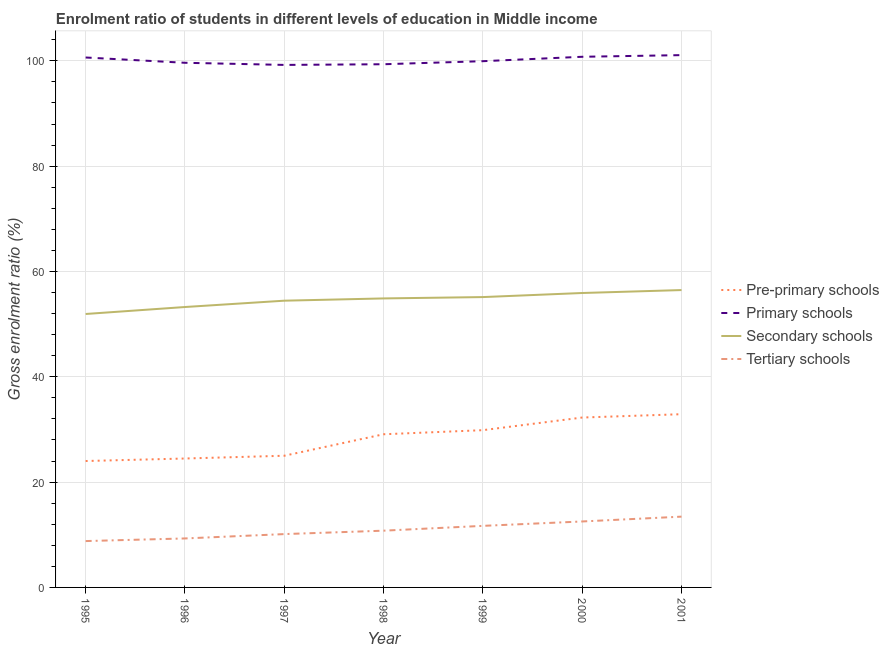Does the line corresponding to gross enrolment ratio in primary schools intersect with the line corresponding to gross enrolment ratio in tertiary schools?
Offer a terse response. No. What is the gross enrolment ratio in tertiary schools in 1995?
Make the answer very short. 8.8. Across all years, what is the maximum gross enrolment ratio in primary schools?
Ensure brevity in your answer.  101.08. Across all years, what is the minimum gross enrolment ratio in primary schools?
Your response must be concise. 99.22. What is the total gross enrolment ratio in primary schools in the graph?
Provide a short and direct response. 700.62. What is the difference between the gross enrolment ratio in secondary schools in 1996 and that in 2000?
Your answer should be very brief. -2.66. What is the difference between the gross enrolment ratio in secondary schools in 1998 and the gross enrolment ratio in primary schools in 1996?
Give a very brief answer. -44.75. What is the average gross enrolment ratio in primary schools per year?
Your response must be concise. 100.09. In the year 2000, what is the difference between the gross enrolment ratio in pre-primary schools and gross enrolment ratio in primary schools?
Your answer should be very brief. -68.51. In how many years, is the gross enrolment ratio in secondary schools greater than 24 %?
Offer a very short reply. 7. What is the ratio of the gross enrolment ratio in secondary schools in 1996 to that in 2000?
Offer a terse response. 0.95. Is the gross enrolment ratio in primary schools in 1998 less than that in 2000?
Make the answer very short. Yes. Is the difference between the gross enrolment ratio in secondary schools in 1996 and 1998 greater than the difference between the gross enrolment ratio in primary schools in 1996 and 1998?
Give a very brief answer. No. What is the difference between the highest and the second highest gross enrolment ratio in secondary schools?
Offer a very short reply. 0.56. What is the difference between the highest and the lowest gross enrolment ratio in secondary schools?
Give a very brief answer. 4.54. In how many years, is the gross enrolment ratio in tertiary schools greater than the average gross enrolment ratio in tertiary schools taken over all years?
Your answer should be very brief. 3. Is it the case that in every year, the sum of the gross enrolment ratio in pre-primary schools and gross enrolment ratio in secondary schools is greater than the sum of gross enrolment ratio in tertiary schools and gross enrolment ratio in primary schools?
Your response must be concise. No. Does the gross enrolment ratio in pre-primary schools monotonically increase over the years?
Offer a terse response. Yes. Is the gross enrolment ratio in secondary schools strictly greater than the gross enrolment ratio in primary schools over the years?
Make the answer very short. No. Is the gross enrolment ratio in tertiary schools strictly less than the gross enrolment ratio in secondary schools over the years?
Offer a terse response. Yes. How many years are there in the graph?
Give a very brief answer. 7. What is the difference between two consecutive major ticks on the Y-axis?
Make the answer very short. 20. Are the values on the major ticks of Y-axis written in scientific E-notation?
Keep it short and to the point. No. Does the graph contain any zero values?
Keep it short and to the point. No. Where does the legend appear in the graph?
Your answer should be very brief. Center right. How many legend labels are there?
Offer a very short reply. 4. What is the title of the graph?
Provide a short and direct response. Enrolment ratio of students in different levels of education in Middle income. What is the label or title of the X-axis?
Offer a very short reply. Year. What is the label or title of the Y-axis?
Offer a very short reply. Gross enrolment ratio (%). What is the Gross enrolment ratio (%) in Pre-primary schools in 1995?
Give a very brief answer. 24.01. What is the Gross enrolment ratio (%) of Primary schools in 1995?
Offer a very short reply. 100.63. What is the Gross enrolment ratio (%) of Secondary schools in 1995?
Give a very brief answer. 51.93. What is the Gross enrolment ratio (%) of Tertiary schools in 1995?
Your answer should be very brief. 8.8. What is the Gross enrolment ratio (%) in Pre-primary schools in 1996?
Give a very brief answer. 24.48. What is the Gross enrolment ratio (%) in Primary schools in 1996?
Your answer should be compact. 99.63. What is the Gross enrolment ratio (%) in Secondary schools in 1996?
Offer a very short reply. 53.25. What is the Gross enrolment ratio (%) in Tertiary schools in 1996?
Your response must be concise. 9.3. What is the Gross enrolment ratio (%) of Pre-primary schools in 1997?
Your answer should be compact. 25.01. What is the Gross enrolment ratio (%) in Primary schools in 1997?
Offer a terse response. 99.22. What is the Gross enrolment ratio (%) of Secondary schools in 1997?
Your answer should be compact. 54.45. What is the Gross enrolment ratio (%) in Tertiary schools in 1997?
Ensure brevity in your answer.  10.13. What is the Gross enrolment ratio (%) of Pre-primary schools in 1998?
Your answer should be very brief. 29.09. What is the Gross enrolment ratio (%) of Primary schools in 1998?
Give a very brief answer. 99.35. What is the Gross enrolment ratio (%) in Secondary schools in 1998?
Provide a short and direct response. 54.88. What is the Gross enrolment ratio (%) in Tertiary schools in 1998?
Offer a very short reply. 10.78. What is the Gross enrolment ratio (%) in Pre-primary schools in 1999?
Provide a short and direct response. 29.86. What is the Gross enrolment ratio (%) in Primary schools in 1999?
Offer a terse response. 99.93. What is the Gross enrolment ratio (%) in Secondary schools in 1999?
Offer a terse response. 55.14. What is the Gross enrolment ratio (%) in Tertiary schools in 1999?
Offer a terse response. 11.69. What is the Gross enrolment ratio (%) in Pre-primary schools in 2000?
Your answer should be compact. 32.26. What is the Gross enrolment ratio (%) of Primary schools in 2000?
Make the answer very short. 100.77. What is the Gross enrolment ratio (%) of Secondary schools in 2000?
Your response must be concise. 55.91. What is the Gross enrolment ratio (%) of Tertiary schools in 2000?
Your response must be concise. 12.53. What is the Gross enrolment ratio (%) in Pre-primary schools in 2001?
Your answer should be very brief. 32.9. What is the Gross enrolment ratio (%) of Primary schools in 2001?
Offer a very short reply. 101.08. What is the Gross enrolment ratio (%) of Secondary schools in 2001?
Keep it short and to the point. 56.47. What is the Gross enrolment ratio (%) in Tertiary schools in 2001?
Ensure brevity in your answer.  13.44. Across all years, what is the maximum Gross enrolment ratio (%) in Pre-primary schools?
Ensure brevity in your answer.  32.9. Across all years, what is the maximum Gross enrolment ratio (%) in Primary schools?
Offer a terse response. 101.08. Across all years, what is the maximum Gross enrolment ratio (%) of Secondary schools?
Provide a short and direct response. 56.47. Across all years, what is the maximum Gross enrolment ratio (%) in Tertiary schools?
Provide a succinct answer. 13.44. Across all years, what is the minimum Gross enrolment ratio (%) in Pre-primary schools?
Your answer should be very brief. 24.01. Across all years, what is the minimum Gross enrolment ratio (%) in Primary schools?
Your answer should be compact. 99.22. Across all years, what is the minimum Gross enrolment ratio (%) of Secondary schools?
Offer a terse response. 51.93. Across all years, what is the minimum Gross enrolment ratio (%) in Tertiary schools?
Keep it short and to the point. 8.8. What is the total Gross enrolment ratio (%) in Pre-primary schools in the graph?
Offer a terse response. 197.6. What is the total Gross enrolment ratio (%) in Primary schools in the graph?
Give a very brief answer. 700.62. What is the total Gross enrolment ratio (%) of Secondary schools in the graph?
Offer a terse response. 382.02. What is the total Gross enrolment ratio (%) in Tertiary schools in the graph?
Make the answer very short. 76.67. What is the difference between the Gross enrolment ratio (%) of Pre-primary schools in 1995 and that in 1996?
Make the answer very short. -0.48. What is the difference between the Gross enrolment ratio (%) of Primary schools in 1995 and that in 1996?
Give a very brief answer. 1. What is the difference between the Gross enrolment ratio (%) of Secondary schools in 1995 and that in 1996?
Offer a very short reply. -1.32. What is the difference between the Gross enrolment ratio (%) of Tertiary schools in 1995 and that in 1996?
Offer a terse response. -0.5. What is the difference between the Gross enrolment ratio (%) of Pre-primary schools in 1995 and that in 1997?
Provide a short and direct response. -1. What is the difference between the Gross enrolment ratio (%) of Primary schools in 1995 and that in 1997?
Provide a succinct answer. 1.41. What is the difference between the Gross enrolment ratio (%) of Secondary schools in 1995 and that in 1997?
Keep it short and to the point. -2.53. What is the difference between the Gross enrolment ratio (%) in Tertiary schools in 1995 and that in 1997?
Offer a terse response. -1.33. What is the difference between the Gross enrolment ratio (%) in Pre-primary schools in 1995 and that in 1998?
Provide a short and direct response. -5.08. What is the difference between the Gross enrolment ratio (%) in Primary schools in 1995 and that in 1998?
Offer a very short reply. 1.28. What is the difference between the Gross enrolment ratio (%) of Secondary schools in 1995 and that in 1998?
Keep it short and to the point. -2.95. What is the difference between the Gross enrolment ratio (%) of Tertiary schools in 1995 and that in 1998?
Offer a very short reply. -1.97. What is the difference between the Gross enrolment ratio (%) of Pre-primary schools in 1995 and that in 1999?
Make the answer very short. -5.86. What is the difference between the Gross enrolment ratio (%) of Primary schools in 1995 and that in 1999?
Give a very brief answer. 0.7. What is the difference between the Gross enrolment ratio (%) of Secondary schools in 1995 and that in 1999?
Make the answer very short. -3.21. What is the difference between the Gross enrolment ratio (%) of Tertiary schools in 1995 and that in 1999?
Your answer should be very brief. -2.89. What is the difference between the Gross enrolment ratio (%) of Pre-primary schools in 1995 and that in 2000?
Keep it short and to the point. -8.26. What is the difference between the Gross enrolment ratio (%) in Primary schools in 1995 and that in 2000?
Your response must be concise. -0.14. What is the difference between the Gross enrolment ratio (%) of Secondary schools in 1995 and that in 2000?
Make the answer very short. -3.99. What is the difference between the Gross enrolment ratio (%) in Tertiary schools in 1995 and that in 2000?
Offer a very short reply. -3.72. What is the difference between the Gross enrolment ratio (%) of Pre-primary schools in 1995 and that in 2001?
Ensure brevity in your answer.  -8.89. What is the difference between the Gross enrolment ratio (%) in Primary schools in 1995 and that in 2001?
Provide a short and direct response. -0.45. What is the difference between the Gross enrolment ratio (%) in Secondary schools in 1995 and that in 2001?
Offer a very short reply. -4.54. What is the difference between the Gross enrolment ratio (%) in Tertiary schools in 1995 and that in 2001?
Make the answer very short. -4.64. What is the difference between the Gross enrolment ratio (%) of Pre-primary schools in 1996 and that in 1997?
Ensure brevity in your answer.  -0.52. What is the difference between the Gross enrolment ratio (%) of Primary schools in 1996 and that in 1997?
Your answer should be very brief. 0.41. What is the difference between the Gross enrolment ratio (%) in Secondary schools in 1996 and that in 1997?
Provide a short and direct response. -1.2. What is the difference between the Gross enrolment ratio (%) in Tertiary schools in 1996 and that in 1997?
Make the answer very short. -0.83. What is the difference between the Gross enrolment ratio (%) in Pre-primary schools in 1996 and that in 1998?
Make the answer very short. -4.6. What is the difference between the Gross enrolment ratio (%) of Primary schools in 1996 and that in 1998?
Ensure brevity in your answer.  0.28. What is the difference between the Gross enrolment ratio (%) of Secondary schools in 1996 and that in 1998?
Your answer should be very brief. -1.63. What is the difference between the Gross enrolment ratio (%) in Tertiary schools in 1996 and that in 1998?
Provide a succinct answer. -1.47. What is the difference between the Gross enrolment ratio (%) in Pre-primary schools in 1996 and that in 1999?
Your response must be concise. -5.38. What is the difference between the Gross enrolment ratio (%) of Primary schools in 1996 and that in 1999?
Your response must be concise. -0.3. What is the difference between the Gross enrolment ratio (%) in Secondary schools in 1996 and that in 1999?
Give a very brief answer. -1.89. What is the difference between the Gross enrolment ratio (%) in Tertiary schools in 1996 and that in 1999?
Your answer should be very brief. -2.39. What is the difference between the Gross enrolment ratio (%) in Pre-primary schools in 1996 and that in 2000?
Give a very brief answer. -7.78. What is the difference between the Gross enrolment ratio (%) in Primary schools in 1996 and that in 2000?
Provide a short and direct response. -1.14. What is the difference between the Gross enrolment ratio (%) in Secondary schools in 1996 and that in 2000?
Provide a short and direct response. -2.66. What is the difference between the Gross enrolment ratio (%) in Tertiary schools in 1996 and that in 2000?
Provide a succinct answer. -3.22. What is the difference between the Gross enrolment ratio (%) of Pre-primary schools in 1996 and that in 2001?
Keep it short and to the point. -8.42. What is the difference between the Gross enrolment ratio (%) in Primary schools in 1996 and that in 2001?
Your answer should be very brief. -1.45. What is the difference between the Gross enrolment ratio (%) of Secondary schools in 1996 and that in 2001?
Make the answer very short. -3.22. What is the difference between the Gross enrolment ratio (%) of Tertiary schools in 1996 and that in 2001?
Ensure brevity in your answer.  -4.14. What is the difference between the Gross enrolment ratio (%) of Pre-primary schools in 1997 and that in 1998?
Provide a succinct answer. -4.08. What is the difference between the Gross enrolment ratio (%) of Primary schools in 1997 and that in 1998?
Give a very brief answer. -0.13. What is the difference between the Gross enrolment ratio (%) of Secondary schools in 1997 and that in 1998?
Make the answer very short. -0.43. What is the difference between the Gross enrolment ratio (%) of Tertiary schools in 1997 and that in 1998?
Give a very brief answer. -0.65. What is the difference between the Gross enrolment ratio (%) of Pre-primary schools in 1997 and that in 1999?
Keep it short and to the point. -4.86. What is the difference between the Gross enrolment ratio (%) in Primary schools in 1997 and that in 1999?
Give a very brief answer. -0.71. What is the difference between the Gross enrolment ratio (%) of Secondary schools in 1997 and that in 1999?
Your response must be concise. -0.69. What is the difference between the Gross enrolment ratio (%) in Tertiary schools in 1997 and that in 1999?
Keep it short and to the point. -1.56. What is the difference between the Gross enrolment ratio (%) in Pre-primary schools in 1997 and that in 2000?
Give a very brief answer. -7.26. What is the difference between the Gross enrolment ratio (%) of Primary schools in 1997 and that in 2000?
Provide a short and direct response. -1.55. What is the difference between the Gross enrolment ratio (%) in Secondary schools in 1997 and that in 2000?
Your response must be concise. -1.46. What is the difference between the Gross enrolment ratio (%) of Tertiary schools in 1997 and that in 2000?
Your response must be concise. -2.4. What is the difference between the Gross enrolment ratio (%) in Pre-primary schools in 1997 and that in 2001?
Your answer should be very brief. -7.89. What is the difference between the Gross enrolment ratio (%) of Primary schools in 1997 and that in 2001?
Make the answer very short. -1.86. What is the difference between the Gross enrolment ratio (%) in Secondary schools in 1997 and that in 2001?
Provide a short and direct response. -2.02. What is the difference between the Gross enrolment ratio (%) of Tertiary schools in 1997 and that in 2001?
Your response must be concise. -3.31. What is the difference between the Gross enrolment ratio (%) of Pre-primary schools in 1998 and that in 1999?
Your answer should be compact. -0.78. What is the difference between the Gross enrolment ratio (%) of Primary schools in 1998 and that in 1999?
Provide a succinct answer. -0.58. What is the difference between the Gross enrolment ratio (%) in Secondary schools in 1998 and that in 1999?
Ensure brevity in your answer.  -0.26. What is the difference between the Gross enrolment ratio (%) in Tertiary schools in 1998 and that in 1999?
Ensure brevity in your answer.  -0.92. What is the difference between the Gross enrolment ratio (%) in Pre-primary schools in 1998 and that in 2000?
Offer a very short reply. -3.18. What is the difference between the Gross enrolment ratio (%) in Primary schools in 1998 and that in 2000?
Offer a very short reply. -1.42. What is the difference between the Gross enrolment ratio (%) in Secondary schools in 1998 and that in 2000?
Make the answer very short. -1.03. What is the difference between the Gross enrolment ratio (%) in Tertiary schools in 1998 and that in 2000?
Your response must be concise. -1.75. What is the difference between the Gross enrolment ratio (%) in Pre-primary schools in 1998 and that in 2001?
Your answer should be very brief. -3.81. What is the difference between the Gross enrolment ratio (%) of Primary schools in 1998 and that in 2001?
Offer a very short reply. -1.73. What is the difference between the Gross enrolment ratio (%) in Secondary schools in 1998 and that in 2001?
Your answer should be very brief. -1.59. What is the difference between the Gross enrolment ratio (%) in Tertiary schools in 1998 and that in 2001?
Give a very brief answer. -2.67. What is the difference between the Gross enrolment ratio (%) in Pre-primary schools in 1999 and that in 2000?
Keep it short and to the point. -2.4. What is the difference between the Gross enrolment ratio (%) in Primary schools in 1999 and that in 2000?
Offer a terse response. -0.84. What is the difference between the Gross enrolment ratio (%) of Secondary schools in 1999 and that in 2000?
Make the answer very short. -0.77. What is the difference between the Gross enrolment ratio (%) in Pre-primary schools in 1999 and that in 2001?
Offer a terse response. -3.03. What is the difference between the Gross enrolment ratio (%) in Primary schools in 1999 and that in 2001?
Keep it short and to the point. -1.15. What is the difference between the Gross enrolment ratio (%) in Secondary schools in 1999 and that in 2001?
Keep it short and to the point. -1.33. What is the difference between the Gross enrolment ratio (%) of Tertiary schools in 1999 and that in 2001?
Your answer should be compact. -1.75. What is the difference between the Gross enrolment ratio (%) of Pre-primary schools in 2000 and that in 2001?
Offer a terse response. -0.64. What is the difference between the Gross enrolment ratio (%) in Primary schools in 2000 and that in 2001?
Offer a very short reply. -0.31. What is the difference between the Gross enrolment ratio (%) in Secondary schools in 2000 and that in 2001?
Provide a short and direct response. -0.56. What is the difference between the Gross enrolment ratio (%) of Tertiary schools in 2000 and that in 2001?
Your answer should be compact. -0.92. What is the difference between the Gross enrolment ratio (%) of Pre-primary schools in 1995 and the Gross enrolment ratio (%) of Primary schools in 1996?
Give a very brief answer. -75.62. What is the difference between the Gross enrolment ratio (%) of Pre-primary schools in 1995 and the Gross enrolment ratio (%) of Secondary schools in 1996?
Offer a terse response. -29.24. What is the difference between the Gross enrolment ratio (%) of Pre-primary schools in 1995 and the Gross enrolment ratio (%) of Tertiary schools in 1996?
Provide a short and direct response. 14.7. What is the difference between the Gross enrolment ratio (%) of Primary schools in 1995 and the Gross enrolment ratio (%) of Secondary schools in 1996?
Provide a short and direct response. 47.38. What is the difference between the Gross enrolment ratio (%) in Primary schools in 1995 and the Gross enrolment ratio (%) in Tertiary schools in 1996?
Ensure brevity in your answer.  91.33. What is the difference between the Gross enrolment ratio (%) of Secondary schools in 1995 and the Gross enrolment ratio (%) of Tertiary schools in 1996?
Give a very brief answer. 42.62. What is the difference between the Gross enrolment ratio (%) in Pre-primary schools in 1995 and the Gross enrolment ratio (%) in Primary schools in 1997?
Give a very brief answer. -75.22. What is the difference between the Gross enrolment ratio (%) of Pre-primary schools in 1995 and the Gross enrolment ratio (%) of Secondary schools in 1997?
Make the answer very short. -30.45. What is the difference between the Gross enrolment ratio (%) of Pre-primary schools in 1995 and the Gross enrolment ratio (%) of Tertiary schools in 1997?
Provide a short and direct response. 13.88. What is the difference between the Gross enrolment ratio (%) in Primary schools in 1995 and the Gross enrolment ratio (%) in Secondary schools in 1997?
Provide a succinct answer. 46.18. What is the difference between the Gross enrolment ratio (%) in Primary schools in 1995 and the Gross enrolment ratio (%) in Tertiary schools in 1997?
Your response must be concise. 90.5. What is the difference between the Gross enrolment ratio (%) in Secondary schools in 1995 and the Gross enrolment ratio (%) in Tertiary schools in 1997?
Make the answer very short. 41.8. What is the difference between the Gross enrolment ratio (%) in Pre-primary schools in 1995 and the Gross enrolment ratio (%) in Primary schools in 1998?
Keep it short and to the point. -75.35. What is the difference between the Gross enrolment ratio (%) in Pre-primary schools in 1995 and the Gross enrolment ratio (%) in Secondary schools in 1998?
Offer a very short reply. -30.88. What is the difference between the Gross enrolment ratio (%) of Pre-primary schools in 1995 and the Gross enrolment ratio (%) of Tertiary schools in 1998?
Give a very brief answer. 13.23. What is the difference between the Gross enrolment ratio (%) in Primary schools in 1995 and the Gross enrolment ratio (%) in Secondary schools in 1998?
Offer a terse response. 45.75. What is the difference between the Gross enrolment ratio (%) of Primary schools in 1995 and the Gross enrolment ratio (%) of Tertiary schools in 1998?
Keep it short and to the point. 89.86. What is the difference between the Gross enrolment ratio (%) in Secondary schools in 1995 and the Gross enrolment ratio (%) in Tertiary schools in 1998?
Provide a succinct answer. 41.15. What is the difference between the Gross enrolment ratio (%) of Pre-primary schools in 1995 and the Gross enrolment ratio (%) of Primary schools in 1999?
Keep it short and to the point. -75.93. What is the difference between the Gross enrolment ratio (%) in Pre-primary schools in 1995 and the Gross enrolment ratio (%) in Secondary schools in 1999?
Offer a very short reply. -31.13. What is the difference between the Gross enrolment ratio (%) of Pre-primary schools in 1995 and the Gross enrolment ratio (%) of Tertiary schools in 1999?
Give a very brief answer. 12.31. What is the difference between the Gross enrolment ratio (%) of Primary schools in 1995 and the Gross enrolment ratio (%) of Secondary schools in 1999?
Your response must be concise. 45.5. What is the difference between the Gross enrolment ratio (%) of Primary schools in 1995 and the Gross enrolment ratio (%) of Tertiary schools in 1999?
Give a very brief answer. 88.94. What is the difference between the Gross enrolment ratio (%) of Secondary schools in 1995 and the Gross enrolment ratio (%) of Tertiary schools in 1999?
Offer a very short reply. 40.23. What is the difference between the Gross enrolment ratio (%) in Pre-primary schools in 1995 and the Gross enrolment ratio (%) in Primary schools in 2000?
Provide a succinct answer. -76.76. What is the difference between the Gross enrolment ratio (%) in Pre-primary schools in 1995 and the Gross enrolment ratio (%) in Secondary schools in 2000?
Offer a very short reply. -31.91. What is the difference between the Gross enrolment ratio (%) of Pre-primary schools in 1995 and the Gross enrolment ratio (%) of Tertiary schools in 2000?
Provide a succinct answer. 11.48. What is the difference between the Gross enrolment ratio (%) of Primary schools in 1995 and the Gross enrolment ratio (%) of Secondary schools in 2000?
Ensure brevity in your answer.  44.72. What is the difference between the Gross enrolment ratio (%) in Primary schools in 1995 and the Gross enrolment ratio (%) in Tertiary schools in 2000?
Make the answer very short. 88.11. What is the difference between the Gross enrolment ratio (%) of Secondary schools in 1995 and the Gross enrolment ratio (%) of Tertiary schools in 2000?
Give a very brief answer. 39.4. What is the difference between the Gross enrolment ratio (%) in Pre-primary schools in 1995 and the Gross enrolment ratio (%) in Primary schools in 2001?
Offer a terse response. -77.08. What is the difference between the Gross enrolment ratio (%) of Pre-primary schools in 1995 and the Gross enrolment ratio (%) of Secondary schools in 2001?
Ensure brevity in your answer.  -32.46. What is the difference between the Gross enrolment ratio (%) in Pre-primary schools in 1995 and the Gross enrolment ratio (%) in Tertiary schools in 2001?
Your answer should be very brief. 10.56. What is the difference between the Gross enrolment ratio (%) in Primary schools in 1995 and the Gross enrolment ratio (%) in Secondary schools in 2001?
Keep it short and to the point. 44.16. What is the difference between the Gross enrolment ratio (%) of Primary schools in 1995 and the Gross enrolment ratio (%) of Tertiary schools in 2001?
Offer a terse response. 87.19. What is the difference between the Gross enrolment ratio (%) of Secondary schools in 1995 and the Gross enrolment ratio (%) of Tertiary schools in 2001?
Give a very brief answer. 38.48. What is the difference between the Gross enrolment ratio (%) of Pre-primary schools in 1996 and the Gross enrolment ratio (%) of Primary schools in 1997?
Ensure brevity in your answer.  -74.74. What is the difference between the Gross enrolment ratio (%) in Pre-primary schools in 1996 and the Gross enrolment ratio (%) in Secondary schools in 1997?
Provide a succinct answer. -29.97. What is the difference between the Gross enrolment ratio (%) in Pre-primary schools in 1996 and the Gross enrolment ratio (%) in Tertiary schools in 1997?
Provide a succinct answer. 14.35. What is the difference between the Gross enrolment ratio (%) of Primary schools in 1996 and the Gross enrolment ratio (%) of Secondary schools in 1997?
Keep it short and to the point. 45.18. What is the difference between the Gross enrolment ratio (%) in Primary schools in 1996 and the Gross enrolment ratio (%) in Tertiary schools in 1997?
Ensure brevity in your answer.  89.5. What is the difference between the Gross enrolment ratio (%) of Secondary schools in 1996 and the Gross enrolment ratio (%) of Tertiary schools in 1997?
Ensure brevity in your answer.  43.12. What is the difference between the Gross enrolment ratio (%) of Pre-primary schools in 1996 and the Gross enrolment ratio (%) of Primary schools in 1998?
Give a very brief answer. -74.87. What is the difference between the Gross enrolment ratio (%) of Pre-primary schools in 1996 and the Gross enrolment ratio (%) of Secondary schools in 1998?
Provide a short and direct response. -30.4. What is the difference between the Gross enrolment ratio (%) of Pre-primary schools in 1996 and the Gross enrolment ratio (%) of Tertiary schools in 1998?
Offer a terse response. 13.7. What is the difference between the Gross enrolment ratio (%) of Primary schools in 1996 and the Gross enrolment ratio (%) of Secondary schools in 1998?
Offer a terse response. 44.75. What is the difference between the Gross enrolment ratio (%) in Primary schools in 1996 and the Gross enrolment ratio (%) in Tertiary schools in 1998?
Give a very brief answer. 88.85. What is the difference between the Gross enrolment ratio (%) of Secondary schools in 1996 and the Gross enrolment ratio (%) of Tertiary schools in 1998?
Your answer should be very brief. 42.47. What is the difference between the Gross enrolment ratio (%) in Pre-primary schools in 1996 and the Gross enrolment ratio (%) in Primary schools in 1999?
Make the answer very short. -75.45. What is the difference between the Gross enrolment ratio (%) of Pre-primary schools in 1996 and the Gross enrolment ratio (%) of Secondary schools in 1999?
Offer a terse response. -30.66. What is the difference between the Gross enrolment ratio (%) in Pre-primary schools in 1996 and the Gross enrolment ratio (%) in Tertiary schools in 1999?
Ensure brevity in your answer.  12.79. What is the difference between the Gross enrolment ratio (%) of Primary schools in 1996 and the Gross enrolment ratio (%) of Secondary schools in 1999?
Your answer should be compact. 44.49. What is the difference between the Gross enrolment ratio (%) in Primary schools in 1996 and the Gross enrolment ratio (%) in Tertiary schools in 1999?
Keep it short and to the point. 87.94. What is the difference between the Gross enrolment ratio (%) of Secondary schools in 1996 and the Gross enrolment ratio (%) of Tertiary schools in 1999?
Your answer should be very brief. 41.56. What is the difference between the Gross enrolment ratio (%) in Pre-primary schools in 1996 and the Gross enrolment ratio (%) in Primary schools in 2000?
Keep it short and to the point. -76.29. What is the difference between the Gross enrolment ratio (%) in Pre-primary schools in 1996 and the Gross enrolment ratio (%) in Secondary schools in 2000?
Provide a succinct answer. -31.43. What is the difference between the Gross enrolment ratio (%) in Pre-primary schools in 1996 and the Gross enrolment ratio (%) in Tertiary schools in 2000?
Make the answer very short. 11.96. What is the difference between the Gross enrolment ratio (%) of Primary schools in 1996 and the Gross enrolment ratio (%) of Secondary schools in 2000?
Offer a very short reply. 43.72. What is the difference between the Gross enrolment ratio (%) of Primary schools in 1996 and the Gross enrolment ratio (%) of Tertiary schools in 2000?
Provide a succinct answer. 87.1. What is the difference between the Gross enrolment ratio (%) of Secondary schools in 1996 and the Gross enrolment ratio (%) of Tertiary schools in 2000?
Offer a terse response. 40.72. What is the difference between the Gross enrolment ratio (%) of Pre-primary schools in 1996 and the Gross enrolment ratio (%) of Primary schools in 2001?
Your answer should be very brief. -76.6. What is the difference between the Gross enrolment ratio (%) in Pre-primary schools in 1996 and the Gross enrolment ratio (%) in Secondary schools in 2001?
Give a very brief answer. -31.99. What is the difference between the Gross enrolment ratio (%) of Pre-primary schools in 1996 and the Gross enrolment ratio (%) of Tertiary schools in 2001?
Provide a short and direct response. 11.04. What is the difference between the Gross enrolment ratio (%) in Primary schools in 1996 and the Gross enrolment ratio (%) in Secondary schools in 2001?
Provide a succinct answer. 43.16. What is the difference between the Gross enrolment ratio (%) of Primary schools in 1996 and the Gross enrolment ratio (%) of Tertiary schools in 2001?
Provide a short and direct response. 86.19. What is the difference between the Gross enrolment ratio (%) in Secondary schools in 1996 and the Gross enrolment ratio (%) in Tertiary schools in 2001?
Offer a terse response. 39.81. What is the difference between the Gross enrolment ratio (%) of Pre-primary schools in 1997 and the Gross enrolment ratio (%) of Primary schools in 1998?
Provide a succinct answer. -74.35. What is the difference between the Gross enrolment ratio (%) of Pre-primary schools in 1997 and the Gross enrolment ratio (%) of Secondary schools in 1998?
Offer a terse response. -29.87. What is the difference between the Gross enrolment ratio (%) in Pre-primary schools in 1997 and the Gross enrolment ratio (%) in Tertiary schools in 1998?
Your answer should be compact. 14.23. What is the difference between the Gross enrolment ratio (%) of Primary schools in 1997 and the Gross enrolment ratio (%) of Secondary schools in 1998?
Ensure brevity in your answer.  44.34. What is the difference between the Gross enrolment ratio (%) of Primary schools in 1997 and the Gross enrolment ratio (%) of Tertiary schools in 1998?
Make the answer very short. 88.45. What is the difference between the Gross enrolment ratio (%) of Secondary schools in 1997 and the Gross enrolment ratio (%) of Tertiary schools in 1998?
Your answer should be compact. 43.67. What is the difference between the Gross enrolment ratio (%) in Pre-primary schools in 1997 and the Gross enrolment ratio (%) in Primary schools in 1999?
Ensure brevity in your answer.  -74.93. What is the difference between the Gross enrolment ratio (%) of Pre-primary schools in 1997 and the Gross enrolment ratio (%) of Secondary schools in 1999?
Make the answer very short. -30.13. What is the difference between the Gross enrolment ratio (%) of Pre-primary schools in 1997 and the Gross enrolment ratio (%) of Tertiary schools in 1999?
Provide a succinct answer. 13.31. What is the difference between the Gross enrolment ratio (%) of Primary schools in 1997 and the Gross enrolment ratio (%) of Secondary schools in 1999?
Your answer should be very brief. 44.09. What is the difference between the Gross enrolment ratio (%) of Primary schools in 1997 and the Gross enrolment ratio (%) of Tertiary schools in 1999?
Provide a succinct answer. 87.53. What is the difference between the Gross enrolment ratio (%) of Secondary schools in 1997 and the Gross enrolment ratio (%) of Tertiary schools in 1999?
Offer a very short reply. 42.76. What is the difference between the Gross enrolment ratio (%) of Pre-primary schools in 1997 and the Gross enrolment ratio (%) of Primary schools in 2000?
Keep it short and to the point. -75.76. What is the difference between the Gross enrolment ratio (%) of Pre-primary schools in 1997 and the Gross enrolment ratio (%) of Secondary schools in 2000?
Your answer should be compact. -30.91. What is the difference between the Gross enrolment ratio (%) of Pre-primary schools in 1997 and the Gross enrolment ratio (%) of Tertiary schools in 2000?
Make the answer very short. 12.48. What is the difference between the Gross enrolment ratio (%) in Primary schools in 1997 and the Gross enrolment ratio (%) in Secondary schools in 2000?
Your answer should be compact. 43.31. What is the difference between the Gross enrolment ratio (%) of Primary schools in 1997 and the Gross enrolment ratio (%) of Tertiary schools in 2000?
Your answer should be very brief. 86.7. What is the difference between the Gross enrolment ratio (%) in Secondary schools in 1997 and the Gross enrolment ratio (%) in Tertiary schools in 2000?
Your response must be concise. 41.93. What is the difference between the Gross enrolment ratio (%) in Pre-primary schools in 1997 and the Gross enrolment ratio (%) in Primary schools in 2001?
Ensure brevity in your answer.  -76.08. What is the difference between the Gross enrolment ratio (%) of Pre-primary schools in 1997 and the Gross enrolment ratio (%) of Secondary schools in 2001?
Make the answer very short. -31.46. What is the difference between the Gross enrolment ratio (%) of Pre-primary schools in 1997 and the Gross enrolment ratio (%) of Tertiary schools in 2001?
Provide a succinct answer. 11.56. What is the difference between the Gross enrolment ratio (%) in Primary schools in 1997 and the Gross enrolment ratio (%) in Secondary schools in 2001?
Offer a terse response. 42.75. What is the difference between the Gross enrolment ratio (%) in Primary schools in 1997 and the Gross enrolment ratio (%) in Tertiary schools in 2001?
Ensure brevity in your answer.  85.78. What is the difference between the Gross enrolment ratio (%) of Secondary schools in 1997 and the Gross enrolment ratio (%) of Tertiary schools in 2001?
Offer a terse response. 41.01. What is the difference between the Gross enrolment ratio (%) of Pre-primary schools in 1998 and the Gross enrolment ratio (%) of Primary schools in 1999?
Offer a terse response. -70.85. What is the difference between the Gross enrolment ratio (%) in Pre-primary schools in 1998 and the Gross enrolment ratio (%) in Secondary schools in 1999?
Your response must be concise. -26.05. What is the difference between the Gross enrolment ratio (%) in Pre-primary schools in 1998 and the Gross enrolment ratio (%) in Tertiary schools in 1999?
Offer a very short reply. 17.39. What is the difference between the Gross enrolment ratio (%) in Primary schools in 1998 and the Gross enrolment ratio (%) in Secondary schools in 1999?
Your response must be concise. 44.21. What is the difference between the Gross enrolment ratio (%) of Primary schools in 1998 and the Gross enrolment ratio (%) of Tertiary schools in 1999?
Give a very brief answer. 87.66. What is the difference between the Gross enrolment ratio (%) of Secondary schools in 1998 and the Gross enrolment ratio (%) of Tertiary schools in 1999?
Offer a terse response. 43.19. What is the difference between the Gross enrolment ratio (%) of Pre-primary schools in 1998 and the Gross enrolment ratio (%) of Primary schools in 2000?
Your response must be concise. -71.68. What is the difference between the Gross enrolment ratio (%) of Pre-primary schools in 1998 and the Gross enrolment ratio (%) of Secondary schools in 2000?
Your answer should be very brief. -26.83. What is the difference between the Gross enrolment ratio (%) in Pre-primary schools in 1998 and the Gross enrolment ratio (%) in Tertiary schools in 2000?
Provide a short and direct response. 16.56. What is the difference between the Gross enrolment ratio (%) in Primary schools in 1998 and the Gross enrolment ratio (%) in Secondary schools in 2000?
Give a very brief answer. 43.44. What is the difference between the Gross enrolment ratio (%) in Primary schools in 1998 and the Gross enrolment ratio (%) in Tertiary schools in 2000?
Your response must be concise. 86.83. What is the difference between the Gross enrolment ratio (%) in Secondary schools in 1998 and the Gross enrolment ratio (%) in Tertiary schools in 2000?
Your response must be concise. 42.36. What is the difference between the Gross enrolment ratio (%) of Pre-primary schools in 1998 and the Gross enrolment ratio (%) of Primary schools in 2001?
Provide a short and direct response. -72. What is the difference between the Gross enrolment ratio (%) in Pre-primary schools in 1998 and the Gross enrolment ratio (%) in Secondary schools in 2001?
Give a very brief answer. -27.38. What is the difference between the Gross enrolment ratio (%) of Pre-primary schools in 1998 and the Gross enrolment ratio (%) of Tertiary schools in 2001?
Give a very brief answer. 15.64. What is the difference between the Gross enrolment ratio (%) of Primary schools in 1998 and the Gross enrolment ratio (%) of Secondary schools in 2001?
Your answer should be very brief. 42.88. What is the difference between the Gross enrolment ratio (%) of Primary schools in 1998 and the Gross enrolment ratio (%) of Tertiary schools in 2001?
Your answer should be compact. 85.91. What is the difference between the Gross enrolment ratio (%) of Secondary schools in 1998 and the Gross enrolment ratio (%) of Tertiary schools in 2001?
Give a very brief answer. 41.44. What is the difference between the Gross enrolment ratio (%) in Pre-primary schools in 1999 and the Gross enrolment ratio (%) in Primary schools in 2000?
Offer a terse response. -70.9. What is the difference between the Gross enrolment ratio (%) of Pre-primary schools in 1999 and the Gross enrolment ratio (%) of Secondary schools in 2000?
Offer a very short reply. -26.05. What is the difference between the Gross enrolment ratio (%) in Pre-primary schools in 1999 and the Gross enrolment ratio (%) in Tertiary schools in 2000?
Provide a short and direct response. 17.34. What is the difference between the Gross enrolment ratio (%) in Primary schools in 1999 and the Gross enrolment ratio (%) in Secondary schools in 2000?
Provide a short and direct response. 44.02. What is the difference between the Gross enrolment ratio (%) in Primary schools in 1999 and the Gross enrolment ratio (%) in Tertiary schools in 2000?
Offer a very short reply. 87.41. What is the difference between the Gross enrolment ratio (%) in Secondary schools in 1999 and the Gross enrolment ratio (%) in Tertiary schools in 2000?
Ensure brevity in your answer.  42.61. What is the difference between the Gross enrolment ratio (%) in Pre-primary schools in 1999 and the Gross enrolment ratio (%) in Primary schools in 2001?
Provide a short and direct response. -71.22. What is the difference between the Gross enrolment ratio (%) of Pre-primary schools in 1999 and the Gross enrolment ratio (%) of Secondary schools in 2001?
Ensure brevity in your answer.  -26.6. What is the difference between the Gross enrolment ratio (%) of Pre-primary schools in 1999 and the Gross enrolment ratio (%) of Tertiary schools in 2001?
Offer a terse response. 16.42. What is the difference between the Gross enrolment ratio (%) of Primary schools in 1999 and the Gross enrolment ratio (%) of Secondary schools in 2001?
Your answer should be compact. 43.46. What is the difference between the Gross enrolment ratio (%) in Primary schools in 1999 and the Gross enrolment ratio (%) in Tertiary schools in 2001?
Your answer should be very brief. 86.49. What is the difference between the Gross enrolment ratio (%) in Secondary schools in 1999 and the Gross enrolment ratio (%) in Tertiary schools in 2001?
Your answer should be compact. 41.69. What is the difference between the Gross enrolment ratio (%) of Pre-primary schools in 2000 and the Gross enrolment ratio (%) of Primary schools in 2001?
Ensure brevity in your answer.  -68.82. What is the difference between the Gross enrolment ratio (%) in Pre-primary schools in 2000 and the Gross enrolment ratio (%) in Secondary schools in 2001?
Give a very brief answer. -24.21. What is the difference between the Gross enrolment ratio (%) in Pre-primary schools in 2000 and the Gross enrolment ratio (%) in Tertiary schools in 2001?
Offer a very short reply. 18.82. What is the difference between the Gross enrolment ratio (%) in Primary schools in 2000 and the Gross enrolment ratio (%) in Secondary schools in 2001?
Give a very brief answer. 44.3. What is the difference between the Gross enrolment ratio (%) in Primary schools in 2000 and the Gross enrolment ratio (%) in Tertiary schools in 2001?
Make the answer very short. 87.33. What is the difference between the Gross enrolment ratio (%) in Secondary schools in 2000 and the Gross enrolment ratio (%) in Tertiary schools in 2001?
Keep it short and to the point. 42.47. What is the average Gross enrolment ratio (%) in Pre-primary schools per year?
Your response must be concise. 28.23. What is the average Gross enrolment ratio (%) of Primary schools per year?
Your answer should be compact. 100.09. What is the average Gross enrolment ratio (%) of Secondary schools per year?
Provide a short and direct response. 54.57. What is the average Gross enrolment ratio (%) in Tertiary schools per year?
Provide a succinct answer. 10.95. In the year 1995, what is the difference between the Gross enrolment ratio (%) in Pre-primary schools and Gross enrolment ratio (%) in Primary schools?
Offer a very short reply. -76.63. In the year 1995, what is the difference between the Gross enrolment ratio (%) in Pre-primary schools and Gross enrolment ratio (%) in Secondary schools?
Your response must be concise. -27.92. In the year 1995, what is the difference between the Gross enrolment ratio (%) in Pre-primary schools and Gross enrolment ratio (%) in Tertiary schools?
Your answer should be compact. 15.2. In the year 1995, what is the difference between the Gross enrolment ratio (%) in Primary schools and Gross enrolment ratio (%) in Secondary schools?
Your answer should be compact. 48.71. In the year 1995, what is the difference between the Gross enrolment ratio (%) in Primary schools and Gross enrolment ratio (%) in Tertiary schools?
Ensure brevity in your answer.  91.83. In the year 1995, what is the difference between the Gross enrolment ratio (%) in Secondary schools and Gross enrolment ratio (%) in Tertiary schools?
Your answer should be compact. 43.12. In the year 1996, what is the difference between the Gross enrolment ratio (%) of Pre-primary schools and Gross enrolment ratio (%) of Primary schools?
Your response must be concise. -75.15. In the year 1996, what is the difference between the Gross enrolment ratio (%) of Pre-primary schools and Gross enrolment ratio (%) of Secondary schools?
Provide a succinct answer. -28.77. In the year 1996, what is the difference between the Gross enrolment ratio (%) of Pre-primary schools and Gross enrolment ratio (%) of Tertiary schools?
Your response must be concise. 15.18. In the year 1996, what is the difference between the Gross enrolment ratio (%) of Primary schools and Gross enrolment ratio (%) of Secondary schools?
Your answer should be compact. 46.38. In the year 1996, what is the difference between the Gross enrolment ratio (%) in Primary schools and Gross enrolment ratio (%) in Tertiary schools?
Make the answer very short. 90.33. In the year 1996, what is the difference between the Gross enrolment ratio (%) in Secondary schools and Gross enrolment ratio (%) in Tertiary schools?
Provide a succinct answer. 43.95. In the year 1997, what is the difference between the Gross enrolment ratio (%) of Pre-primary schools and Gross enrolment ratio (%) of Primary schools?
Ensure brevity in your answer.  -74.22. In the year 1997, what is the difference between the Gross enrolment ratio (%) in Pre-primary schools and Gross enrolment ratio (%) in Secondary schools?
Offer a terse response. -29.45. In the year 1997, what is the difference between the Gross enrolment ratio (%) of Pre-primary schools and Gross enrolment ratio (%) of Tertiary schools?
Provide a short and direct response. 14.88. In the year 1997, what is the difference between the Gross enrolment ratio (%) of Primary schools and Gross enrolment ratio (%) of Secondary schools?
Offer a terse response. 44.77. In the year 1997, what is the difference between the Gross enrolment ratio (%) of Primary schools and Gross enrolment ratio (%) of Tertiary schools?
Provide a succinct answer. 89.09. In the year 1997, what is the difference between the Gross enrolment ratio (%) in Secondary schools and Gross enrolment ratio (%) in Tertiary schools?
Your answer should be compact. 44.32. In the year 1998, what is the difference between the Gross enrolment ratio (%) in Pre-primary schools and Gross enrolment ratio (%) in Primary schools?
Provide a succinct answer. -70.27. In the year 1998, what is the difference between the Gross enrolment ratio (%) of Pre-primary schools and Gross enrolment ratio (%) of Secondary schools?
Offer a terse response. -25.79. In the year 1998, what is the difference between the Gross enrolment ratio (%) in Pre-primary schools and Gross enrolment ratio (%) in Tertiary schools?
Offer a terse response. 18.31. In the year 1998, what is the difference between the Gross enrolment ratio (%) in Primary schools and Gross enrolment ratio (%) in Secondary schools?
Keep it short and to the point. 44.47. In the year 1998, what is the difference between the Gross enrolment ratio (%) of Primary schools and Gross enrolment ratio (%) of Tertiary schools?
Make the answer very short. 88.58. In the year 1998, what is the difference between the Gross enrolment ratio (%) in Secondary schools and Gross enrolment ratio (%) in Tertiary schools?
Keep it short and to the point. 44.1. In the year 1999, what is the difference between the Gross enrolment ratio (%) in Pre-primary schools and Gross enrolment ratio (%) in Primary schools?
Give a very brief answer. -70.07. In the year 1999, what is the difference between the Gross enrolment ratio (%) in Pre-primary schools and Gross enrolment ratio (%) in Secondary schools?
Provide a succinct answer. -25.27. In the year 1999, what is the difference between the Gross enrolment ratio (%) of Pre-primary schools and Gross enrolment ratio (%) of Tertiary schools?
Your response must be concise. 18.17. In the year 1999, what is the difference between the Gross enrolment ratio (%) of Primary schools and Gross enrolment ratio (%) of Secondary schools?
Offer a terse response. 44.8. In the year 1999, what is the difference between the Gross enrolment ratio (%) of Primary schools and Gross enrolment ratio (%) of Tertiary schools?
Make the answer very short. 88.24. In the year 1999, what is the difference between the Gross enrolment ratio (%) in Secondary schools and Gross enrolment ratio (%) in Tertiary schools?
Provide a succinct answer. 43.45. In the year 2000, what is the difference between the Gross enrolment ratio (%) in Pre-primary schools and Gross enrolment ratio (%) in Primary schools?
Provide a succinct answer. -68.51. In the year 2000, what is the difference between the Gross enrolment ratio (%) of Pre-primary schools and Gross enrolment ratio (%) of Secondary schools?
Make the answer very short. -23.65. In the year 2000, what is the difference between the Gross enrolment ratio (%) in Pre-primary schools and Gross enrolment ratio (%) in Tertiary schools?
Your answer should be compact. 19.74. In the year 2000, what is the difference between the Gross enrolment ratio (%) in Primary schools and Gross enrolment ratio (%) in Secondary schools?
Your answer should be compact. 44.86. In the year 2000, what is the difference between the Gross enrolment ratio (%) of Primary schools and Gross enrolment ratio (%) of Tertiary schools?
Your response must be concise. 88.24. In the year 2000, what is the difference between the Gross enrolment ratio (%) of Secondary schools and Gross enrolment ratio (%) of Tertiary schools?
Your answer should be compact. 43.39. In the year 2001, what is the difference between the Gross enrolment ratio (%) in Pre-primary schools and Gross enrolment ratio (%) in Primary schools?
Your answer should be very brief. -68.19. In the year 2001, what is the difference between the Gross enrolment ratio (%) in Pre-primary schools and Gross enrolment ratio (%) in Secondary schools?
Your response must be concise. -23.57. In the year 2001, what is the difference between the Gross enrolment ratio (%) in Pre-primary schools and Gross enrolment ratio (%) in Tertiary schools?
Provide a short and direct response. 19.46. In the year 2001, what is the difference between the Gross enrolment ratio (%) in Primary schools and Gross enrolment ratio (%) in Secondary schools?
Offer a terse response. 44.61. In the year 2001, what is the difference between the Gross enrolment ratio (%) of Primary schools and Gross enrolment ratio (%) of Tertiary schools?
Ensure brevity in your answer.  87.64. In the year 2001, what is the difference between the Gross enrolment ratio (%) of Secondary schools and Gross enrolment ratio (%) of Tertiary schools?
Provide a short and direct response. 43.03. What is the ratio of the Gross enrolment ratio (%) in Pre-primary schools in 1995 to that in 1996?
Your answer should be compact. 0.98. What is the ratio of the Gross enrolment ratio (%) in Secondary schools in 1995 to that in 1996?
Offer a terse response. 0.98. What is the ratio of the Gross enrolment ratio (%) in Tertiary schools in 1995 to that in 1996?
Your answer should be very brief. 0.95. What is the ratio of the Gross enrolment ratio (%) in Pre-primary schools in 1995 to that in 1997?
Make the answer very short. 0.96. What is the ratio of the Gross enrolment ratio (%) in Primary schools in 1995 to that in 1997?
Offer a terse response. 1.01. What is the ratio of the Gross enrolment ratio (%) of Secondary schools in 1995 to that in 1997?
Offer a very short reply. 0.95. What is the ratio of the Gross enrolment ratio (%) in Tertiary schools in 1995 to that in 1997?
Provide a succinct answer. 0.87. What is the ratio of the Gross enrolment ratio (%) in Pre-primary schools in 1995 to that in 1998?
Keep it short and to the point. 0.83. What is the ratio of the Gross enrolment ratio (%) of Primary schools in 1995 to that in 1998?
Offer a very short reply. 1.01. What is the ratio of the Gross enrolment ratio (%) in Secondary schools in 1995 to that in 1998?
Ensure brevity in your answer.  0.95. What is the ratio of the Gross enrolment ratio (%) in Tertiary schools in 1995 to that in 1998?
Offer a very short reply. 0.82. What is the ratio of the Gross enrolment ratio (%) of Pre-primary schools in 1995 to that in 1999?
Give a very brief answer. 0.8. What is the ratio of the Gross enrolment ratio (%) in Primary schools in 1995 to that in 1999?
Your answer should be very brief. 1.01. What is the ratio of the Gross enrolment ratio (%) in Secondary schools in 1995 to that in 1999?
Ensure brevity in your answer.  0.94. What is the ratio of the Gross enrolment ratio (%) of Tertiary schools in 1995 to that in 1999?
Ensure brevity in your answer.  0.75. What is the ratio of the Gross enrolment ratio (%) in Pre-primary schools in 1995 to that in 2000?
Your answer should be very brief. 0.74. What is the ratio of the Gross enrolment ratio (%) in Primary schools in 1995 to that in 2000?
Ensure brevity in your answer.  1. What is the ratio of the Gross enrolment ratio (%) of Secondary schools in 1995 to that in 2000?
Your answer should be very brief. 0.93. What is the ratio of the Gross enrolment ratio (%) in Tertiary schools in 1995 to that in 2000?
Make the answer very short. 0.7. What is the ratio of the Gross enrolment ratio (%) of Pre-primary schools in 1995 to that in 2001?
Keep it short and to the point. 0.73. What is the ratio of the Gross enrolment ratio (%) in Primary schools in 1995 to that in 2001?
Provide a succinct answer. 1. What is the ratio of the Gross enrolment ratio (%) of Secondary schools in 1995 to that in 2001?
Offer a very short reply. 0.92. What is the ratio of the Gross enrolment ratio (%) in Tertiary schools in 1995 to that in 2001?
Provide a short and direct response. 0.65. What is the ratio of the Gross enrolment ratio (%) in Pre-primary schools in 1996 to that in 1997?
Offer a very short reply. 0.98. What is the ratio of the Gross enrolment ratio (%) in Secondary schools in 1996 to that in 1997?
Offer a very short reply. 0.98. What is the ratio of the Gross enrolment ratio (%) of Tertiary schools in 1996 to that in 1997?
Your answer should be compact. 0.92. What is the ratio of the Gross enrolment ratio (%) in Pre-primary schools in 1996 to that in 1998?
Offer a very short reply. 0.84. What is the ratio of the Gross enrolment ratio (%) in Secondary schools in 1996 to that in 1998?
Your response must be concise. 0.97. What is the ratio of the Gross enrolment ratio (%) of Tertiary schools in 1996 to that in 1998?
Keep it short and to the point. 0.86. What is the ratio of the Gross enrolment ratio (%) of Pre-primary schools in 1996 to that in 1999?
Offer a terse response. 0.82. What is the ratio of the Gross enrolment ratio (%) in Secondary schools in 1996 to that in 1999?
Give a very brief answer. 0.97. What is the ratio of the Gross enrolment ratio (%) of Tertiary schools in 1996 to that in 1999?
Give a very brief answer. 0.8. What is the ratio of the Gross enrolment ratio (%) of Pre-primary schools in 1996 to that in 2000?
Provide a succinct answer. 0.76. What is the ratio of the Gross enrolment ratio (%) of Primary schools in 1996 to that in 2000?
Ensure brevity in your answer.  0.99. What is the ratio of the Gross enrolment ratio (%) in Secondary schools in 1996 to that in 2000?
Your answer should be very brief. 0.95. What is the ratio of the Gross enrolment ratio (%) of Tertiary schools in 1996 to that in 2000?
Provide a short and direct response. 0.74. What is the ratio of the Gross enrolment ratio (%) in Pre-primary schools in 1996 to that in 2001?
Provide a succinct answer. 0.74. What is the ratio of the Gross enrolment ratio (%) in Primary schools in 1996 to that in 2001?
Your answer should be compact. 0.99. What is the ratio of the Gross enrolment ratio (%) of Secondary schools in 1996 to that in 2001?
Provide a succinct answer. 0.94. What is the ratio of the Gross enrolment ratio (%) of Tertiary schools in 1996 to that in 2001?
Give a very brief answer. 0.69. What is the ratio of the Gross enrolment ratio (%) in Pre-primary schools in 1997 to that in 1998?
Your answer should be compact. 0.86. What is the ratio of the Gross enrolment ratio (%) in Primary schools in 1997 to that in 1998?
Keep it short and to the point. 1. What is the ratio of the Gross enrolment ratio (%) in Secondary schools in 1997 to that in 1998?
Give a very brief answer. 0.99. What is the ratio of the Gross enrolment ratio (%) of Tertiary schools in 1997 to that in 1998?
Your answer should be compact. 0.94. What is the ratio of the Gross enrolment ratio (%) of Pre-primary schools in 1997 to that in 1999?
Keep it short and to the point. 0.84. What is the ratio of the Gross enrolment ratio (%) in Secondary schools in 1997 to that in 1999?
Offer a terse response. 0.99. What is the ratio of the Gross enrolment ratio (%) in Tertiary schools in 1997 to that in 1999?
Your response must be concise. 0.87. What is the ratio of the Gross enrolment ratio (%) in Pre-primary schools in 1997 to that in 2000?
Offer a terse response. 0.78. What is the ratio of the Gross enrolment ratio (%) of Primary schools in 1997 to that in 2000?
Your response must be concise. 0.98. What is the ratio of the Gross enrolment ratio (%) in Secondary schools in 1997 to that in 2000?
Your response must be concise. 0.97. What is the ratio of the Gross enrolment ratio (%) of Tertiary schools in 1997 to that in 2000?
Give a very brief answer. 0.81. What is the ratio of the Gross enrolment ratio (%) in Pre-primary schools in 1997 to that in 2001?
Make the answer very short. 0.76. What is the ratio of the Gross enrolment ratio (%) in Primary schools in 1997 to that in 2001?
Keep it short and to the point. 0.98. What is the ratio of the Gross enrolment ratio (%) of Secondary schools in 1997 to that in 2001?
Ensure brevity in your answer.  0.96. What is the ratio of the Gross enrolment ratio (%) of Tertiary schools in 1997 to that in 2001?
Provide a succinct answer. 0.75. What is the ratio of the Gross enrolment ratio (%) of Pre-primary schools in 1998 to that in 1999?
Offer a very short reply. 0.97. What is the ratio of the Gross enrolment ratio (%) of Primary schools in 1998 to that in 1999?
Keep it short and to the point. 0.99. What is the ratio of the Gross enrolment ratio (%) of Tertiary schools in 1998 to that in 1999?
Your answer should be compact. 0.92. What is the ratio of the Gross enrolment ratio (%) of Pre-primary schools in 1998 to that in 2000?
Give a very brief answer. 0.9. What is the ratio of the Gross enrolment ratio (%) of Primary schools in 1998 to that in 2000?
Your response must be concise. 0.99. What is the ratio of the Gross enrolment ratio (%) of Secondary schools in 1998 to that in 2000?
Provide a short and direct response. 0.98. What is the ratio of the Gross enrolment ratio (%) of Tertiary schools in 1998 to that in 2000?
Your answer should be very brief. 0.86. What is the ratio of the Gross enrolment ratio (%) in Pre-primary schools in 1998 to that in 2001?
Provide a short and direct response. 0.88. What is the ratio of the Gross enrolment ratio (%) of Primary schools in 1998 to that in 2001?
Offer a terse response. 0.98. What is the ratio of the Gross enrolment ratio (%) in Secondary schools in 1998 to that in 2001?
Offer a terse response. 0.97. What is the ratio of the Gross enrolment ratio (%) of Tertiary schools in 1998 to that in 2001?
Make the answer very short. 0.8. What is the ratio of the Gross enrolment ratio (%) of Pre-primary schools in 1999 to that in 2000?
Keep it short and to the point. 0.93. What is the ratio of the Gross enrolment ratio (%) in Primary schools in 1999 to that in 2000?
Make the answer very short. 0.99. What is the ratio of the Gross enrolment ratio (%) of Secondary schools in 1999 to that in 2000?
Make the answer very short. 0.99. What is the ratio of the Gross enrolment ratio (%) of Tertiary schools in 1999 to that in 2000?
Your answer should be very brief. 0.93. What is the ratio of the Gross enrolment ratio (%) in Pre-primary schools in 1999 to that in 2001?
Your answer should be compact. 0.91. What is the ratio of the Gross enrolment ratio (%) of Secondary schools in 1999 to that in 2001?
Offer a very short reply. 0.98. What is the ratio of the Gross enrolment ratio (%) in Tertiary schools in 1999 to that in 2001?
Offer a very short reply. 0.87. What is the ratio of the Gross enrolment ratio (%) of Pre-primary schools in 2000 to that in 2001?
Give a very brief answer. 0.98. What is the ratio of the Gross enrolment ratio (%) in Secondary schools in 2000 to that in 2001?
Keep it short and to the point. 0.99. What is the ratio of the Gross enrolment ratio (%) in Tertiary schools in 2000 to that in 2001?
Offer a very short reply. 0.93. What is the difference between the highest and the second highest Gross enrolment ratio (%) in Pre-primary schools?
Offer a very short reply. 0.64. What is the difference between the highest and the second highest Gross enrolment ratio (%) of Primary schools?
Your answer should be compact. 0.31. What is the difference between the highest and the second highest Gross enrolment ratio (%) in Secondary schools?
Offer a very short reply. 0.56. What is the difference between the highest and the second highest Gross enrolment ratio (%) of Tertiary schools?
Your answer should be very brief. 0.92. What is the difference between the highest and the lowest Gross enrolment ratio (%) of Pre-primary schools?
Provide a short and direct response. 8.89. What is the difference between the highest and the lowest Gross enrolment ratio (%) of Primary schools?
Your response must be concise. 1.86. What is the difference between the highest and the lowest Gross enrolment ratio (%) in Secondary schools?
Offer a terse response. 4.54. What is the difference between the highest and the lowest Gross enrolment ratio (%) of Tertiary schools?
Keep it short and to the point. 4.64. 